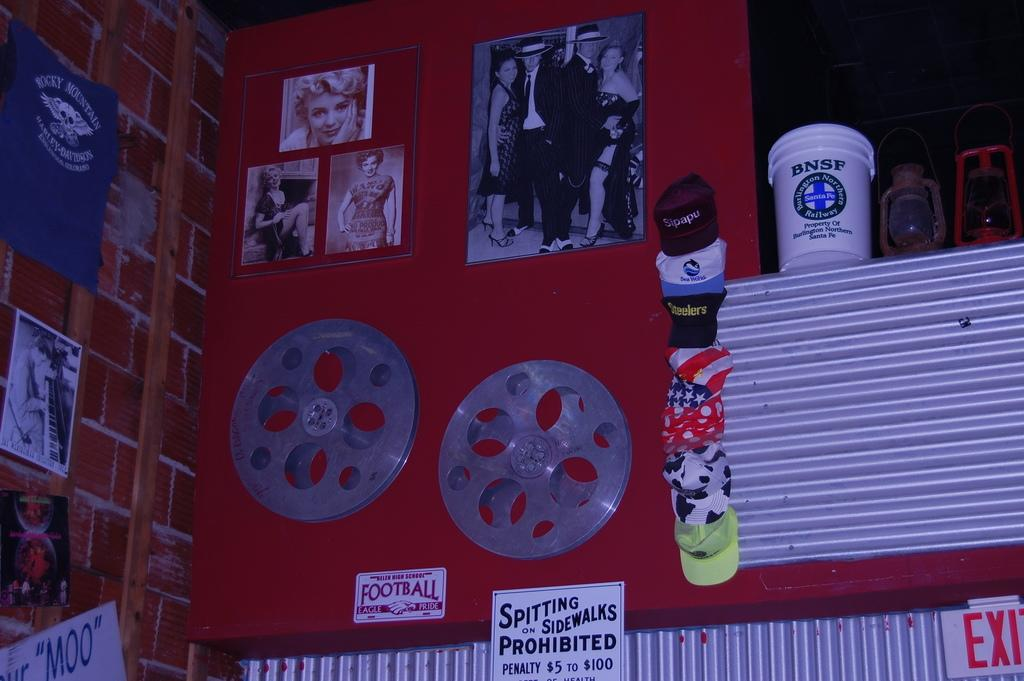<image>
Share a concise interpretation of the image provided. The inside of a room with photos and items including a spitting on sidewalks prohibited poster. 